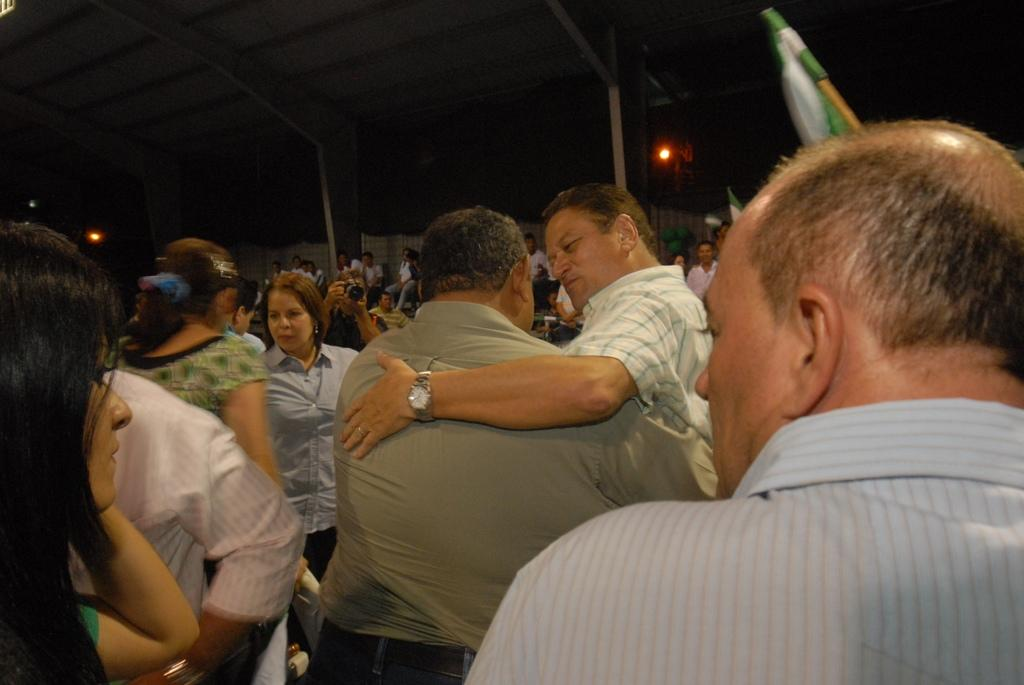What is the main subject of the image? The main subject of the image is people in the center. What else can be seen in the image besides the people? There is a flag in the image. What is visible at the top of the image? There is a ceiling visible at the top of the image. What type of eggs are being used in the argument depicted in the image? There is no argument or eggs present in the image; it features people and a flag. What scientific discovery is being made in the image? There is no scientific discovery being made in the image; it features people and a flag. 